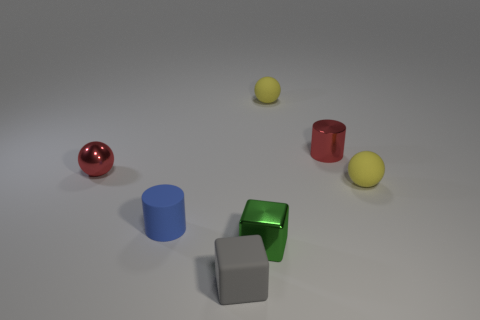How many objects are either tiny red things or tiny red cylinders? In the image, there is one small red sphere and one small red cylinder, making a total of two tiny red objects as described. 